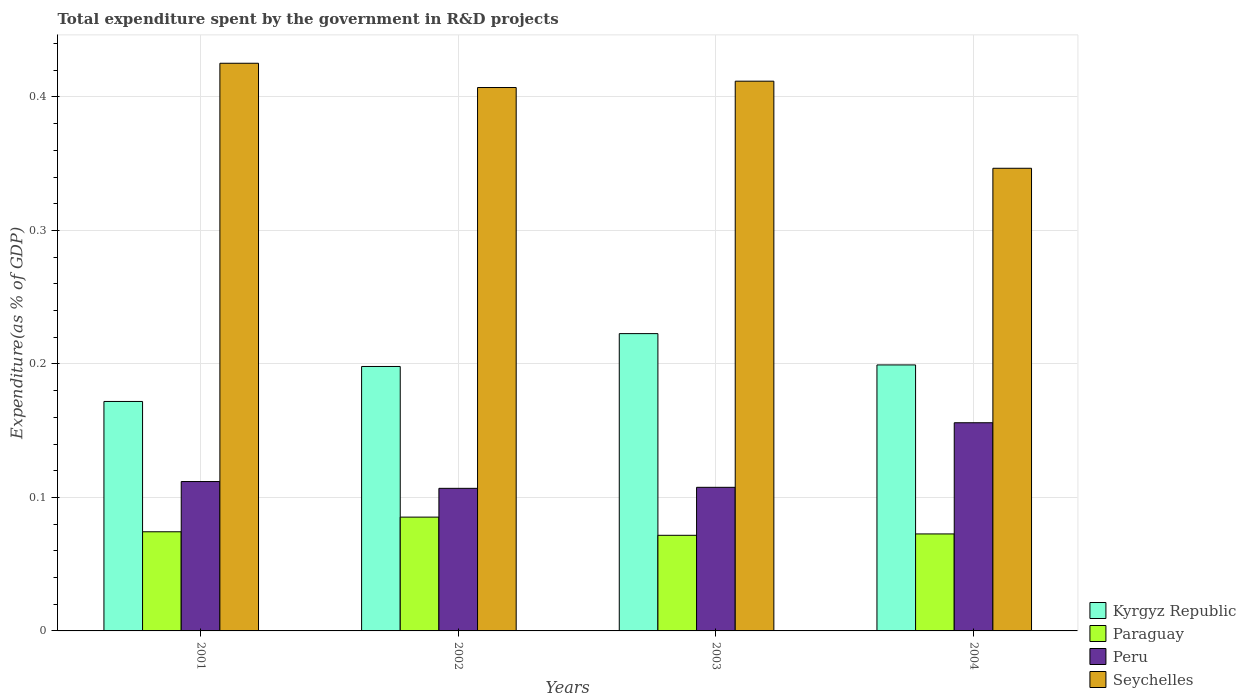Are the number of bars per tick equal to the number of legend labels?
Make the answer very short. Yes. Are the number of bars on each tick of the X-axis equal?
Your answer should be very brief. Yes. How many bars are there on the 1st tick from the left?
Ensure brevity in your answer.  4. How many bars are there on the 2nd tick from the right?
Make the answer very short. 4. What is the label of the 4th group of bars from the left?
Provide a short and direct response. 2004. What is the total expenditure spent by the government in R&D projects in Seychelles in 2001?
Ensure brevity in your answer.  0.43. Across all years, what is the maximum total expenditure spent by the government in R&D projects in Peru?
Provide a short and direct response. 0.16. Across all years, what is the minimum total expenditure spent by the government in R&D projects in Kyrgyz Republic?
Offer a very short reply. 0.17. In which year was the total expenditure spent by the government in R&D projects in Kyrgyz Republic maximum?
Your response must be concise. 2003. What is the total total expenditure spent by the government in R&D projects in Peru in the graph?
Make the answer very short. 0.48. What is the difference between the total expenditure spent by the government in R&D projects in Kyrgyz Republic in 2002 and that in 2004?
Offer a terse response. -0. What is the difference between the total expenditure spent by the government in R&D projects in Kyrgyz Republic in 2003 and the total expenditure spent by the government in R&D projects in Peru in 2004?
Provide a short and direct response. 0.07. What is the average total expenditure spent by the government in R&D projects in Paraguay per year?
Your response must be concise. 0.08. In the year 2001, what is the difference between the total expenditure spent by the government in R&D projects in Seychelles and total expenditure spent by the government in R&D projects in Kyrgyz Republic?
Ensure brevity in your answer.  0.25. In how many years, is the total expenditure spent by the government in R&D projects in Paraguay greater than 0.1 %?
Keep it short and to the point. 0. What is the ratio of the total expenditure spent by the government in R&D projects in Kyrgyz Republic in 2001 to that in 2003?
Ensure brevity in your answer.  0.77. Is the total expenditure spent by the government in R&D projects in Kyrgyz Republic in 2001 less than that in 2002?
Give a very brief answer. Yes. Is the difference between the total expenditure spent by the government in R&D projects in Seychelles in 2002 and 2003 greater than the difference between the total expenditure spent by the government in R&D projects in Kyrgyz Republic in 2002 and 2003?
Give a very brief answer. Yes. What is the difference between the highest and the second highest total expenditure spent by the government in R&D projects in Paraguay?
Your answer should be compact. 0.01. What is the difference between the highest and the lowest total expenditure spent by the government in R&D projects in Peru?
Your response must be concise. 0.05. In how many years, is the total expenditure spent by the government in R&D projects in Paraguay greater than the average total expenditure spent by the government in R&D projects in Paraguay taken over all years?
Offer a very short reply. 1. Is it the case that in every year, the sum of the total expenditure spent by the government in R&D projects in Kyrgyz Republic and total expenditure spent by the government in R&D projects in Peru is greater than the sum of total expenditure spent by the government in R&D projects in Paraguay and total expenditure spent by the government in R&D projects in Seychelles?
Ensure brevity in your answer.  No. What does the 3rd bar from the left in 2003 represents?
Provide a succinct answer. Peru. What does the 2nd bar from the right in 2003 represents?
Provide a short and direct response. Peru. How many bars are there?
Offer a very short reply. 16. Are all the bars in the graph horizontal?
Make the answer very short. No. How many years are there in the graph?
Your answer should be compact. 4. What is the difference between two consecutive major ticks on the Y-axis?
Offer a terse response. 0.1. Are the values on the major ticks of Y-axis written in scientific E-notation?
Give a very brief answer. No. Does the graph contain grids?
Your answer should be compact. Yes. What is the title of the graph?
Your answer should be very brief. Total expenditure spent by the government in R&D projects. What is the label or title of the Y-axis?
Offer a very short reply. Expenditure(as % of GDP). What is the Expenditure(as % of GDP) of Kyrgyz Republic in 2001?
Provide a succinct answer. 0.17. What is the Expenditure(as % of GDP) in Paraguay in 2001?
Your answer should be compact. 0.07. What is the Expenditure(as % of GDP) in Peru in 2001?
Your response must be concise. 0.11. What is the Expenditure(as % of GDP) in Seychelles in 2001?
Keep it short and to the point. 0.43. What is the Expenditure(as % of GDP) in Kyrgyz Republic in 2002?
Give a very brief answer. 0.2. What is the Expenditure(as % of GDP) of Paraguay in 2002?
Keep it short and to the point. 0.09. What is the Expenditure(as % of GDP) of Peru in 2002?
Your response must be concise. 0.11. What is the Expenditure(as % of GDP) in Seychelles in 2002?
Your answer should be very brief. 0.41. What is the Expenditure(as % of GDP) of Kyrgyz Republic in 2003?
Provide a succinct answer. 0.22. What is the Expenditure(as % of GDP) of Paraguay in 2003?
Offer a very short reply. 0.07. What is the Expenditure(as % of GDP) of Peru in 2003?
Make the answer very short. 0.11. What is the Expenditure(as % of GDP) of Seychelles in 2003?
Provide a short and direct response. 0.41. What is the Expenditure(as % of GDP) of Kyrgyz Republic in 2004?
Provide a short and direct response. 0.2. What is the Expenditure(as % of GDP) of Paraguay in 2004?
Your response must be concise. 0.07. What is the Expenditure(as % of GDP) of Peru in 2004?
Give a very brief answer. 0.16. What is the Expenditure(as % of GDP) of Seychelles in 2004?
Your answer should be compact. 0.35. Across all years, what is the maximum Expenditure(as % of GDP) of Kyrgyz Republic?
Provide a succinct answer. 0.22. Across all years, what is the maximum Expenditure(as % of GDP) of Paraguay?
Offer a terse response. 0.09. Across all years, what is the maximum Expenditure(as % of GDP) in Peru?
Provide a succinct answer. 0.16. Across all years, what is the maximum Expenditure(as % of GDP) in Seychelles?
Offer a very short reply. 0.43. Across all years, what is the minimum Expenditure(as % of GDP) in Kyrgyz Republic?
Provide a succinct answer. 0.17. Across all years, what is the minimum Expenditure(as % of GDP) in Paraguay?
Offer a terse response. 0.07. Across all years, what is the minimum Expenditure(as % of GDP) in Peru?
Make the answer very short. 0.11. Across all years, what is the minimum Expenditure(as % of GDP) in Seychelles?
Make the answer very short. 0.35. What is the total Expenditure(as % of GDP) of Kyrgyz Republic in the graph?
Your answer should be compact. 0.79. What is the total Expenditure(as % of GDP) of Paraguay in the graph?
Make the answer very short. 0.3. What is the total Expenditure(as % of GDP) in Peru in the graph?
Your answer should be very brief. 0.48. What is the total Expenditure(as % of GDP) in Seychelles in the graph?
Ensure brevity in your answer.  1.59. What is the difference between the Expenditure(as % of GDP) of Kyrgyz Republic in 2001 and that in 2002?
Provide a short and direct response. -0.03. What is the difference between the Expenditure(as % of GDP) of Paraguay in 2001 and that in 2002?
Your answer should be compact. -0.01. What is the difference between the Expenditure(as % of GDP) of Peru in 2001 and that in 2002?
Make the answer very short. 0.01. What is the difference between the Expenditure(as % of GDP) in Seychelles in 2001 and that in 2002?
Ensure brevity in your answer.  0.02. What is the difference between the Expenditure(as % of GDP) of Kyrgyz Republic in 2001 and that in 2003?
Provide a short and direct response. -0.05. What is the difference between the Expenditure(as % of GDP) in Paraguay in 2001 and that in 2003?
Your response must be concise. 0. What is the difference between the Expenditure(as % of GDP) in Peru in 2001 and that in 2003?
Provide a short and direct response. 0. What is the difference between the Expenditure(as % of GDP) of Seychelles in 2001 and that in 2003?
Provide a succinct answer. 0.01. What is the difference between the Expenditure(as % of GDP) in Kyrgyz Republic in 2001 and that in 2004?
Your response must be concise. -0.03. What is the difference between the Expenditure(as % of GDP) of Paraguay in 2001 and that in 2004?
Offer a terse response. 0. What is the difference between the Expenditure(as % of GDP) of Peru in 2001 and that in 2004?
Your answer should be compact. -0.04. What is the difference between the Expenditure(as % of GDP) in Seychelles in 2001 and that in 2004?
Ensure brevity in your answer.  0.08. What is the difference between the Expenditure(as % of GDP) in Kyrgyz Republic in 2002 and that in 2003?
Ensure brevity in your answer.  -0.02. What is the difference between the Expenditure(as % of GDP) in Paraguay in 2002 and that in 2003?
Offer a terse response. 0.01. What is the difference between the Expenditure(as % of GDP) of Peru in 2002 and that in 2003?
Your response must be concise. -0. What is the difference between the Expenditure(as % of GDP) of Seychelles in 2002 and that in 2003?
Your response must be concise. -0. What is the difference between the Expenditure(as % of GDP) in Kyrgyz Republic in 2002 and that in 2004?
Your response must be concise. -0. What is the difference between the Expenditure(as % of GDP) in Paraguay in 2002 and that in 2004?
Make the answer very short. 0.01. What is the difference between the Expenditure(as % of GDP) of Peru in 2002 and that in 2004?
Ensure brevity in your answer.  -0.05. What is the difference between the Expenditure(as % of GDP) of Seychelles in 2002 and that in 2004?
Keep it short and to the point. 0.06. What is the difference between the Expenditure(as % of GDP) of Kyrgyz Republic in 2003 and that in 2004?
Offer a very short reply. 0.02. What is the difference between the Expenditure(as % of GDP) of Paraguay in 2003 and that in 2004?
Make the answer very short. -0. What is the difference between the Expenditure(as % of GDP) in Peru in 2003 and that in 2004?
Offer a terse response. -0.05. What is the difference between the Expenditure(as % of GDP) of Seychelles in 2003 and that in 2004?
Provide a succinct answer. 0.07. What is the difference between the Expenditure(as % of GDP) in Kyrgyz Republic in 2001 and the Expenditure(as % of GDP) in Paraguay in 2002?
Your answer should be very brief. 0.09. What is the difference between the Expenditure(as % of GDP) in Kyrgyz Republic in 2001 and the Expenditure(as % of GDP) in Peru in 2002?
Provide a succinct answer. 0.07. What is the difference between the Expenditure(as % of GDP) of Kyrgyz Republic in 2001 and the Expenditure(as % of GDP) of Seychelles in 2002?
Your response must be concise. -0.24. What is the difference between the Expenditure(as % of GDP) of Paraguay in 2001 and the Expenditure(as % of GDP) of Peru in 2002?
Offer a terse response. -0.03. What is the difference between the Expenditure(as % of GDP) in Paraguay in 2001 and the Expenditure(as % of GDP) in Seychelles in 2002?
Ensure brevity in your answer.  -0.33. What is the difference between the Expenditure(as % of GDP) of Peru in 2001 and the Expenditure(as % of GDP) of Seychelles in 2002?
Provide a succinct answer. -0.3. What is the difference between the Expenditure(as % of GDP) of Kyrgyz Republic in 2001 and the Expenditure(as % of GDP) of Paraguay in 2003?
Your answer should be compact. 0.1. What is the difference between the Expenditure(as % of GDP) in Kyrgyz Republic in 2001 and the Expenditure(as % of GDP) in Peru in 2003?
Make the answer very short. 0.06. What is the difference between the Expenditure(as % of GDP) of Kyrgyz Republic in 2001 and the Expenditure(as % of GDP) of Seychelles in 2003?
Keep it short and to the point. -0.24. What is the difference between the Expenditure(as % of GDP) of Paraguay in 2001 and the Expenditure(as % of GDP) of Peru in 2003?
Offer a very short reply. -0.03. What is the difference between the Expenditure(as % of GDP) of Paraguay in 2001 and the Expenditure(as % of GDP) of Seychelles in 2003?
Offer a very short reply. -0.34. What is the difference between the Expenditure(as % of GDP) in Peru in 2001 and the Expenditure(as % of GDP) in Seychelles in 2003?
Ensure brevity in your answer.  -0.3. What is the difference between the Expenditure(as % of GDP) in Kyrgyz Republic in 2001 and the Expenditure(as % of GDP) in Paraguay in 2004?
Your response must be concise. 0.1. What is the difference between the Expenditure(as % of GDP) of Kyrgyz Republic in 2001 and the Expenditure(as % of GDP) of Peru in 2004?
Offer a very short reply. 0.02. What is the difference between the Expenditure(as % of GDP) in Kyrgyz Republic in 2001 and the Expenditure(as % of GDP) in Seychelles in 2004?
Make the answer very short. -0.17. What is the difference between the Expenditure(as % of GDP) in Paraguay in 2001 and the Expenditure(as % of GDP) in Peru in 2004?
Make the answer very short. -0.08. What is the difference between the Expenditure(as % of GDP) of Paraguay in 2001 and the Expenditure(as % of GDP) of Seychelles in 2004?
Ensure brevity in your answer.  -0.27. What is the difference between the Expenditure(as % of GDP) in Peru in 2001 and the Expenditure(as % of GDP) in Seychelles in 2004?
Ensure brevity in your answer.  -0.23. What is the difference between the Expenditure(as % of GDP) of Kyrgyz Republic in 2002 and the Expenditure(as % of GDP) of Paraguay in 2003?
Your answer should be compact. 0.13. What is the difference between the Expenditure(as % of GDP) in Kyrgyz Republic in 2002 and the Expenditure(as % of GDP) in Peru in 2003?
Your answer should be very brief. 0.09. What is the difference between the Expenditure(as % of GDP) of Kyrgyz Republic in 2002 and the Expenditure(as % of GDP) of Seychelles in 2003?
Provide a short and direct response. -0.21. What is the difference between the Expenditure(as % of GDP) in Paraguay in 2002 and the Expenditure(as % of GDP) in Peru in 2003?
Your response must be concise. -0.02. What is the difference between the Expenditure(as % of GDP) of Paraguay in 2002 and the Expenditure(as % of GDP) of Seychelles in 2003?
Offer a very short reply. -0.33. What is the difference between the Expenditure(as % of GDP) of Peru in 2002 and the Expenditure(as % of GDP) of Seychelles in 2003?
Provide a succinct answer. -0.3. What is the difference between the Expenditure(as % of GDP) of Kyrgyz Republic in 2002 and the Expenditure(as % of GDP) of Paraguay in 2004?
Ensure brevity in your answer.  0.13. What is the difference between the Expenditure(as % of GDP) in Kyrgyz Republic in 2002 and the Expenditure(as % of GDP) in Peru in 2004?
Your answer should be very brief. 0.04. What is the difference between the Expenditure(as % of GDP) in Kyrgyz Republic in 2002 and the Expenditure(as % of GDP) in Seychelles in 2004?
Your answer should be compact. -0.15. What is the difference between the Expenditure(as % of GDP) in Paraguay in 2002 and the Expenditure(as % of GDP) in Peru in 2004?
Your response must be concise. -0.07. What is the difference between the Expenditure(as % of GDP) of Paraguay in 2002 and the Expenditure(as % of GDP) of Seychelles in 2004?
Make the answer very short. -0.26. What is the difference between the Expenditure(as % of GDP) of Peru in 2002 and the Expenditure(as % of GDP) of Seychelles in 2004?
Make the answer very short. -0.24. What is the difference between the Expenditure(as % of GDP) in Kyrgyz Republic in 2003 and the Expenditure(as % of GDP) in Paraguay in 2004?
Make the answer very short. 0.15. What is the difference between the Expenditure(as % of GDP) of Kyrgyz Republic in 2003 and the Expenditure(as % of GDP) of Peru in 2004?
Offer a terse response. 0.07. What is the difference between the Expenditure(as % of GDP) in Kyrgyz Republic in 2003 and the Expenditure(as % of GDP) in Seychelles in 2004?
Provide a succinct answer. -0.12. What is the difference between the Expenditure(as % of GDP) of Paraguay in 2003 and the Expenditure(as % of GDP) of Peru in 2004?
Your response must be concise. -0.08. What is the difference between the Expenditure(as % of GDP) in Paraguay in 2003 and the Expenditure(as % of GDP) in Seychelles in 2004?
Give a very brief answer. -0.28. What is the difference between the Expenditure(as % of GDP) of Peru in 2003 and the Expenditure(as % of GDP) of Seychelles in 2004?
Give a very brief answer. -0.24. What is the average Expenditure(as % of GDP) in Kyrgyz Republic per year?
Give a very brief answer. 0.2. What is the average Expenditure(as % of GDP) of Paraguay per year?
Offer a very short reply. 0.08. What is the average Expenditure(as % of GDP) of Peru per year?
Keep it short and to the point. 0.12. What is the average Expenditure(as % of GDP) of Seychelles per year?
Your response must be concise. 0.4. In the year 2001, what is the difference between the Expenditure(as % of GDP) in Kyrgyz Republic and Expenditure(as % of GDP) in Paraguay?
Give a very brief answer. 0.1. In the year 2001, what is the difference between the Expenditure(as % of GDP) in Kyrgyz Republic and Expenditure(as % of GDP) in Peru?
Provide a short and direct response. 0.06. In the year 2001, what is the difference between the Expenditure(as % of GDP) of Kyrgyz Republic and Expenditure(as % of GDP) of Seychelles?
Your response must be concise. -0.25. In the year 2001, what is the difference between the Expenditure(as % of GDP) of Paraguay and Expenditure(as % of GDP) of Peru?
Your answer should be very brief. -0.04. In the year 2001, what is the difference between the Expenditure(as % of GDP) in Paraguay and Expenditure(as % of GDP) in Seychelles?
Ensure brevity in your answer.  -0.35. In the year 2001, what is the difference between the Expenditure(as % of GDP) in Peru and Expenditure(as % of GDP) in Seychelles?
Provide a succinct answer. -0.31. In the year 2002, what is the difference between the Expenditure(as % of GDP) in Kyrgyz Republic and Expenditure(as % of GDP) in Paraguay?
Your answer should be very brief. 0.11. In the year 2002, what is the difference between the Expenditure(as % of GDP) in Kyrgyz Republic and Expenditure(as % of GDP) in Peru?
Your response must be concise. 0.09. In the year 2002, what is the difference between the Expenditure(as % of GDP) of Kyrgyz Republic and Expenditure(as % of GDP) of Seychelles?
Ensure brevity in your answer.  -0.21. In the year 2002, what is the difference between the Expenditure(as % of GDP) in Paraguay and Expenditure(as % of GDP) in Peru?
Make the answer very short. -0.02. In the year 2002, what is the difference between the Expenditure(as % of GDP) of Paraguay and Expenditure(as % of GDP) of Seychelles?
Offer a very short reply. -0.32. In the year 2002, what is the difference between the Expenditure(as % of GDP) of Peru and Expenditure(as % of GDP) of Seychelles?
Your answer should be very brief. -0.3. In the year 2003, what is the difference between the Expenditure(as % of GDP) in Kyrgyz Republic and Expenditure(as % of GDP) in Paraguay?
Keep it short and to the point. 0.15. In the year 2003, what is the difference between the Expenditure(as % of GDP) in Kyrgyz Republic and Expenditure(as % of GDP) in Peru?
Your answer should be very brief. 0.12. In the year 2003, what is the difference between the Expenditure(as % of GDP) of Kyrgyz Republic and Expenditure(as % of GDP) of Seychelles?
Give a very brief answer. -0.19. In the year 2003, what is the difference between the Expenditure(as % of GDP) in Paraguay and Expenditure(as % of GDP) in Peru?
Provide a short and direct response. -0.04. In the year 2003, what is the difference between the Expenditure(as % of GDP) of Paraguay and Expenditure(as % of GDP) of Seychelles?
Provide a succinct answer. -0.34. In the year 2003, what is the difference between the Expenditure(as % of GDP) of Peru and Expenditure(as % of GDP) of Seychelles?
Make the answer very short. -0.3. In the year 2004, what is the difference between the Expenditure(as % of GDP) of Kyrgyz Republic and Expenditure(as % of GDP) of Paraguay?
Your response must be concise. 0.13. In the year 2004, what is the difference between the Expenditure(as % of GDP) in Kyrgyz Republic and Expenditure(as % of GDP) in Peru?
Offer a very short reply. 0.04. In the year 2004, what is the difference between the Expenditure(as % of GDP) of Kyrgyz Republic and Expenditure(as % of GDP) of Seychelles?
Offer a terse response. -0.15. In the year 2004, what is the difference between the Expenditure(as % of GDP) of Paraguay and Expenditure(as % of GDP) of Peru?
Provide a short and direct response. -0.08. In the year 2004, what is the difference between the Expenditure(as % of GDP) of Paraguay and Expenditure(as % of GDP) of Seychelles?
Offer a terse response. -0.27. In the year 2004, what is the difference between the Expenditure(as % of GDP) of Peru and Expenditure(as % of GDP) of Seychelles?
Give a very brief answer. -0.19. What is the ratio of the Expenditure(as % of GDP) of Kyrgyz Republic in 2001 to that in 2002?
Offer a very short reply. 0.87. What is the ratio of the Expenditure(as % of GDP) of Paraguay in 2001 to that in 2002?
Your response must be concise. 0.87. What is the ratio of the Expenditure(as % of GDP) of Peru in 2001 to that in 2002?
Your answer should be compact. 1.05. What is the ratio of the Expenditure(as % of GDP) in Seychelles in 2001 to that in 2002?
Provide a succinct answer. 1.04. What is the ratio of the Expenditure(as % of GDP) in Kyrgyz Republic in 2001 to that in 2003?
Keep it short and to the point. 0.77. What is the ratio of the Expenditure(as % of GDP) in Paraguay in 2001 to that in 2003?
Ensure brevity in your answer.  1.04. What is the ratio of the Expenditure(as % of GDP) in Peru in 2001 to that in 2003?
Ensure brevity in your answer.  1.04. What is the ratio of the Expenditure(as % of GDP) in Seychelles in 2001 to that in 2003?
Offer a very short reply. 1.03. What is the ratio of the Expenditure(as % of GDP) of Kyrgyz Republic in 2001 to that in 2004?
Your response must be concise. 0.86. What is the ratio of the Expenditure(as % of GDP) in Paraguay in 2001 to that in 2004?
Give a very brief answer. 1.02. What is the ratio of the Expenditure(as % of GDP) of Peru in 2001 to that in 2004?
Give a very brief answer. 0.72. What is the ratio of the Expenditure(as % of GDP) in Seychelles in 2001 to that in 2004?
Provide a succinct answer. 1.23. What is the ratio of the Expenditure(as % of GDP) in Kyrgyz Republic in 2002 to that in 2003?
Offer a terse response. 0.89. What is the ratio of the Expenditure(as % of GDP) of Paraguay in 2002 to that in 2003?
Your answer should be very brief. 1.19. What is the ratio of the Expenditure(as % of GDP) of Peru in 2002 to that in 2003?
Make the answer very short. 0.99. What is the ratio of the Expenditure(as % of GDP) in Seychelles in 2002 to that in 2003?
Offer a very short reply. 0.99. What is the ratio of the Expenditure(as % of GDP) in Paraguay in 2002 to that in 2004?
Provide a short and direct response. 1.17. What is the ratio of the Expenditure(as % of GDP) of Peru in 2002 to that in 2004?
Give a very brief answer. 0.68. What is the ratio of the Expenditure(as % of GDP) in Seychelles in 2002 to that in 2004?
Make the answer very short. 1.17. What is the ratio of the Expenditure(as % of GDP) of Kyrgyz Republic in 2003 to that in 2004?
Offer a terse response. 1.12. What is the ratio of the Expenditure(as % of GDP) in Paraguay in 2003 to that in 2004?
Your answer should be compact. 0.99. What is the ratio of the Expenditure(as % of GDP) in Peru in 2003 to that in 2004?
Provide a short and direct response. 0.69. What is the ratio of the Expenditure(as % of GDP) in Seychelles in 2003 to that in 2004?
Offer a very short reply. 1.19. What is the difference between the highest and the second highest Expenditure(as % of GDP) in Kyrgyz Republic?
Offer a very short reply. 0.02. What is the difference between the highest and the second highest Expenditure(as % of GDP) of Paraguay?
Offer a very short reply. 0.01. What is the difference between the highest and the second highest Expenditure(as % of GDP) in Peru?
Offer a very short reply. 0.04. What is the difference between the highest and the second highest Expenditure(as % of GDP) in Seychelles?
Give a very brief answer. 0.01. What is the difference between the highest and the lowest Expenditure(as % of GDP) in Kyrgyz Republic?
Offer a terse response. 0.05. What is the difference between the highest and the lowest Expenditure(as % of GDP) in Paraguay?
Make the answer very short. 0.01. What is the difference between the highest and the lowest Expenditure(as % of GDP) of Peru?
Ensure brevity in your answer.  0.05. What is the difference between the highest and the lowest Expenditure(as % of GDP) in Seychelles?
Ensure brevity in your answer.  0.08. 